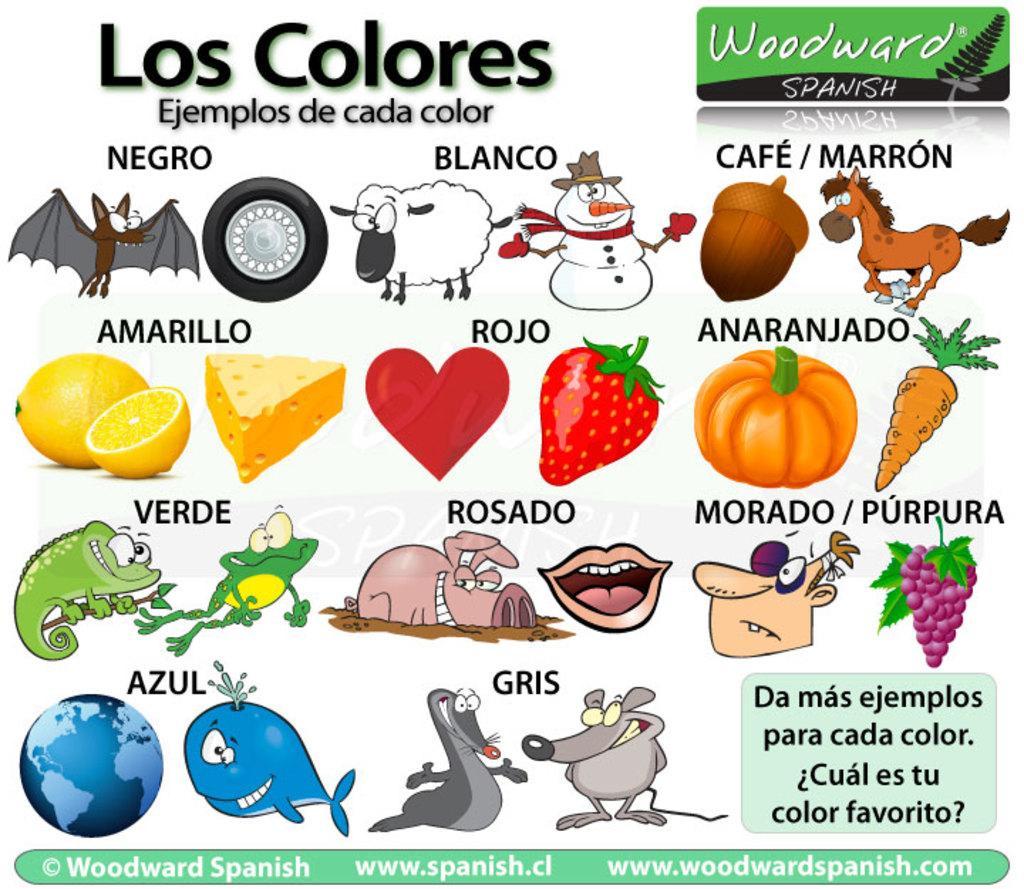Can you describe this image briefly? In this picture I can see a poster. There are words and images on the poster. 